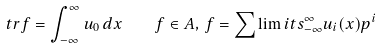Convert formula to latex. <formula><loc_0><loc_0><loc_500><loc_500>t r f = \int _ { - \infty } ^ { \infty } u _ { 0 } \, d x \quad f \in A , \, f = \sum \lim i t s _ { - \infty } ^ { \infty } u _ { i } ( x ) p ^ { i }</formula> 